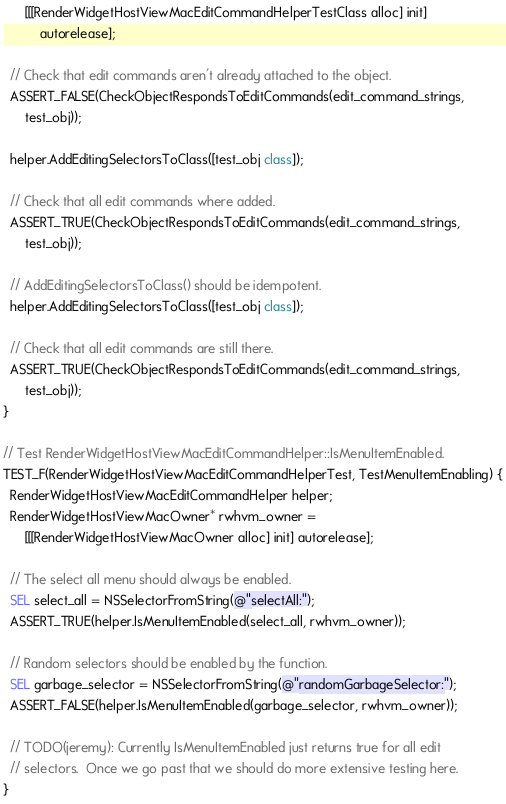<code> <loc_0><loc_0><loc_500><loc_500><_ObjectiveC_>      [[[RenderWidgetHostViewMacEditCommandHelperTestClass alloc] init]
          autorelease];

  // Check that edit commands aren't already attached to the object.
  ASSERT_FALSE(CheckObjectRespondsToEditCommands(edit_command_strings,
      test_obj));

  helper.AddEditingSelectorsToClass([test_obj class]);

  // Check that all edit commands where added.
  ASSERT_TRUE(CheckObjectRespondsToEditCommands(edit_command_strings,
      test_obj));

  // AddEditingSelectorsToClass() should be idempotent.
  helper.AddEditingSelectorsToClass([test_obj class]);

  // Check that all edit commands are still there.
  ASSERT_TRUE(CheckObjectRespondsToEditCommands(edit_command_strings,
      test_obj));
}

// Test RenderWidgetHostViewMacEditCommandHelper::IsMenuItemEnabled.
TEST_F(RenderWidgetHostViewMacEditCommandHelperTest, TestMenuItemEnabling) {
  RenderWidgetHostViewMacEditCommandHelper helper;
  RenderWidgetHostViewMacOwner* rwhvm_owner =
      [[[RenderWidgetHostViewMacOwner alloc] init] autorelease];

  // The select all menu should always be enabled.
  SEL select_all = NSSelectorFromString(@"selectAll:");
  ASSERT_TRUE(helper.IsMenuItemEnabled(select_all, rwhvm_owner));

  // Random selectors should be enabled by the function.
  SEL garbage_selector = NSSelectorFromString(@"randomGarbageSelector:");
  ASSERT_FALSE(helper.IsMenuItemEnabled(garbage_selector, rwhvm_owner));

  // TODO(jeremy): Currently IsMenuItemEnabled just returns true for all edit
  // selectors.  Once we go past that we should do more extensive testing here.
}
</code> 